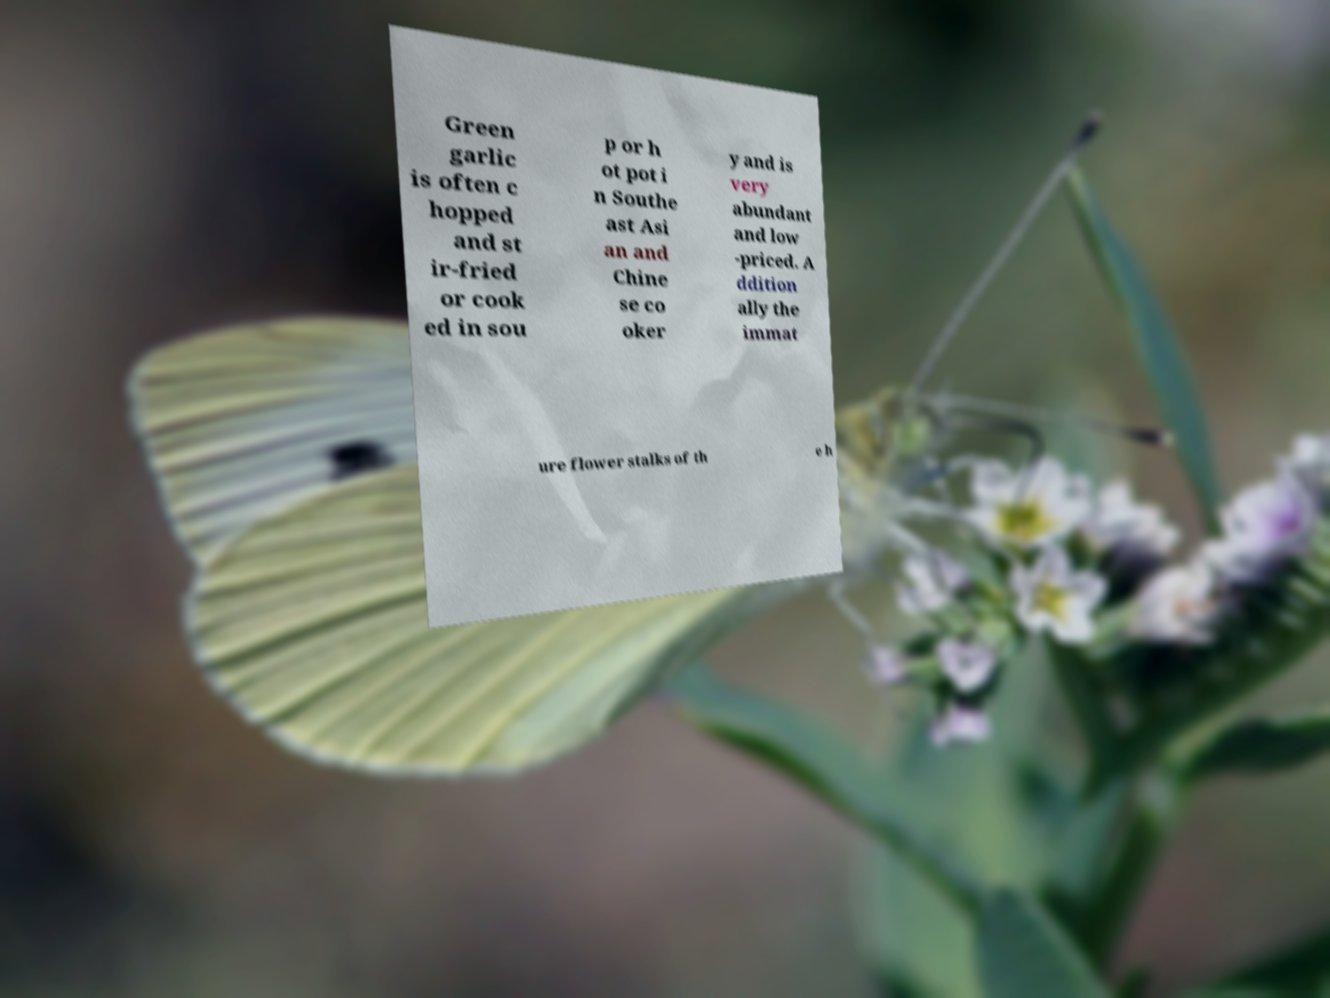Could you assist in decoding the text presented in this image and type it out clearly? Green garlic is often c hopped and st ir-fried or cook ed in sou p or h ot pot i n Southe ast Asi an and Chine se co oker y and is very abundant and low -priced. A ddition ally the immat ure flower stalks of th e h 